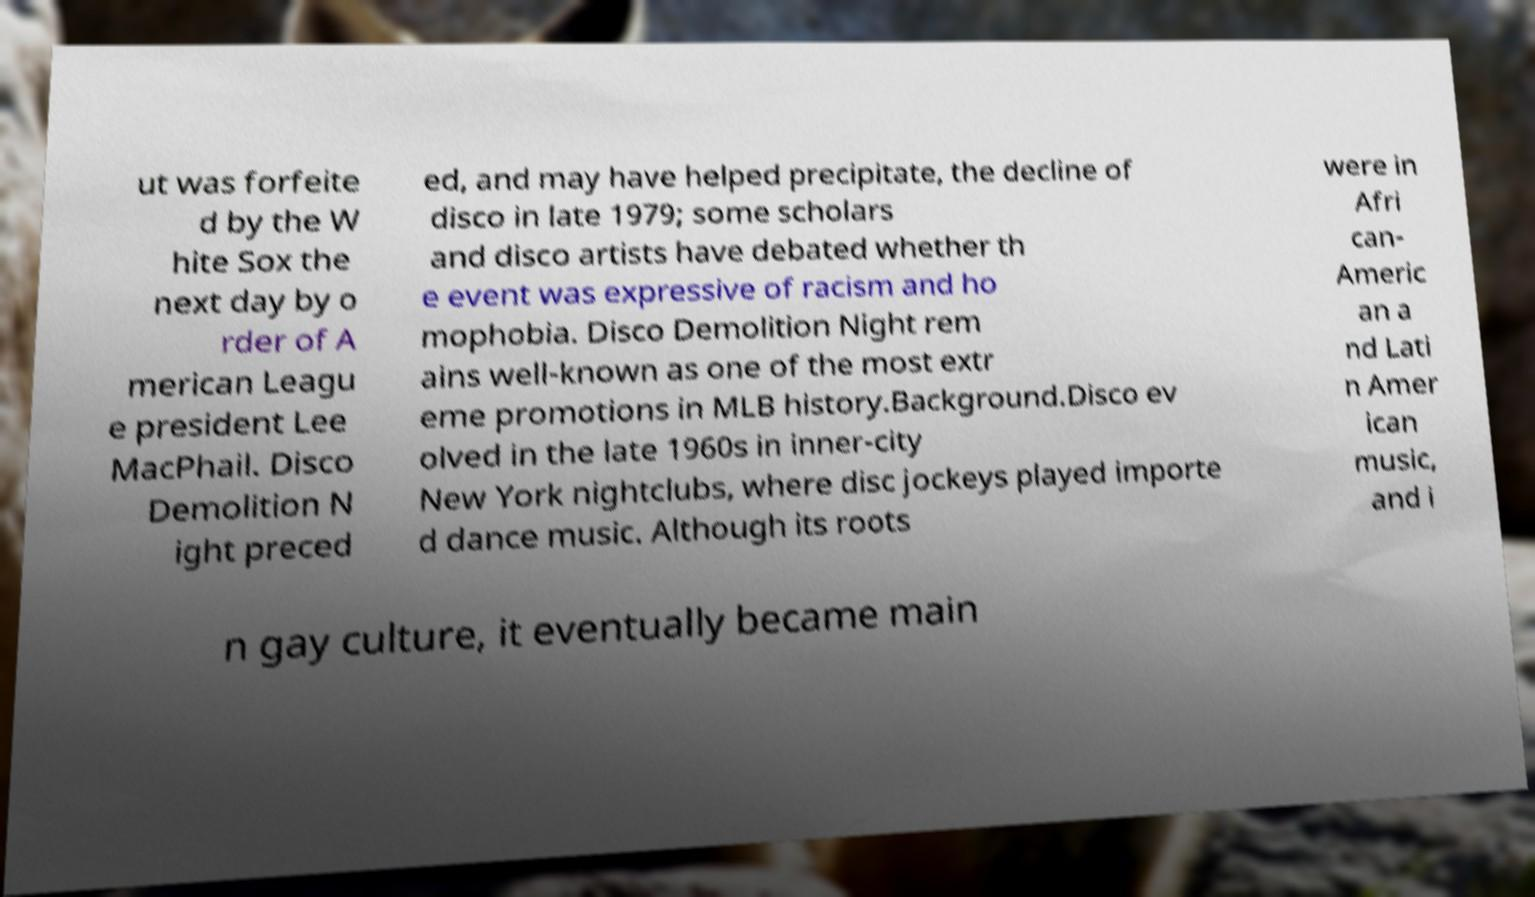Can you accurately transcribe the text from the provided image for me? ut was forfeite d by the W hite Sox the next day by o rder of A merican Leagu e president Lee MacPhail. Disco Demolition N ight preced ed, and may have helped precipitate, the decline of disco in late 1979; some scholars and disco artists have debated whether th e event was expressive of racism and ho mophobia. Disco Demolition Night rem ains well-known as one of the most extr eme promotions in MLB history.Background.Disco ev olved in the late 1960s in inner-city New York nightclubs, where disc jockeys played importe d dance music. Although its roots were in Afri can- Americ an a nd Lati n Amer ican music, and i n gay culture, it eventually became main 